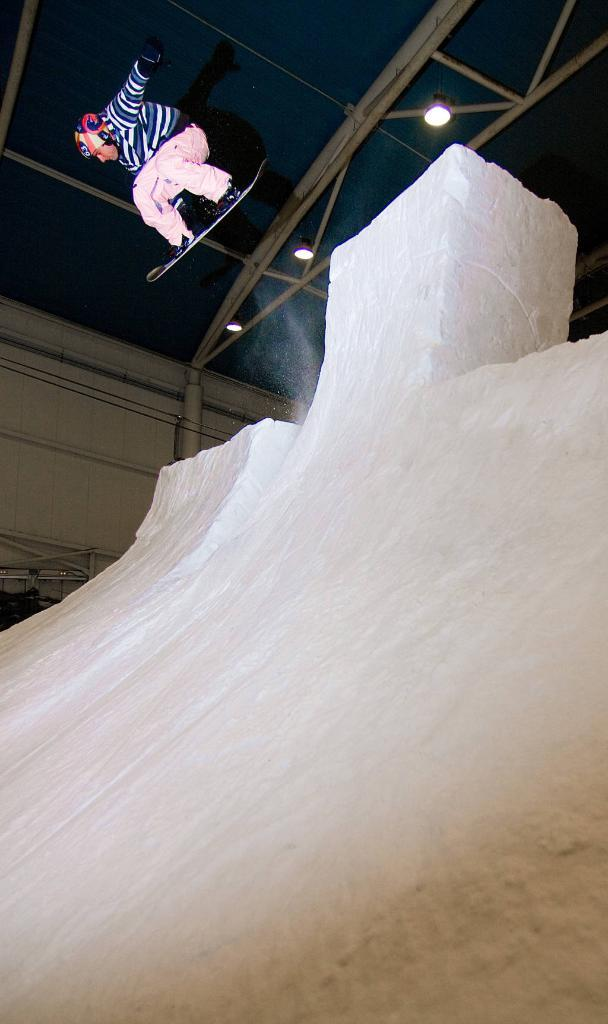What is the main subject of the image? There is a person in the image. What activity is the person engaged in? The person is on a skiing board. Where is the person skiing? There is an ice rink in the image. What can be seen in the background of the image? There is a wall in the background of the image. What type of stew is being served in the image? There is no stew present in the image; it features a person skiing on an ice rink. What direction is the sun setting in the image? The image does not show the sun or any indication of a sunset. 